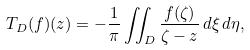<formula> <loc_0><loc_0><loc_500><loc_500>T _ { D } ( f ) ( z ) = - \frac { 1 } { \pi } \iint _ { D } \frac { f ( \zeta ) } { \zeta - z } \, d \xi \, d \eta ,</formula> 